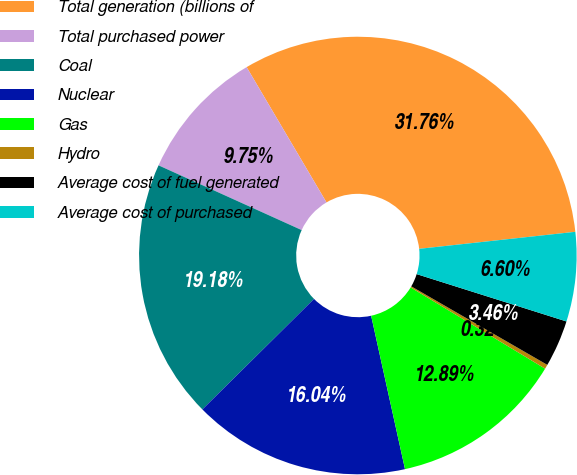Convert chart to OTSL. <chart><loc_0><loc_0><loc_500><loc_500><pie_chart><fcel>Total generation (billions of<fcel>Total purchased power<fcel>Coal<fcel>Nuclear<fcel>Gas<fcel>Hydro<fcel>Average cost of fuel generated<fcel>Average cost of purchased<nl><fcel>31.76%<fcel>9.75%<fcel>19.18%<fcel>16.04%<fcel>12.89%<fcel>0.32%<fcel>3.46%<fcel>6.6%<nl></chart> 